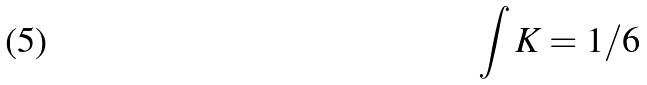Convert formula to latex. <formula><loc_0><loc_0><loc_500><loc_500>\int K = 1 / 6</formula> 